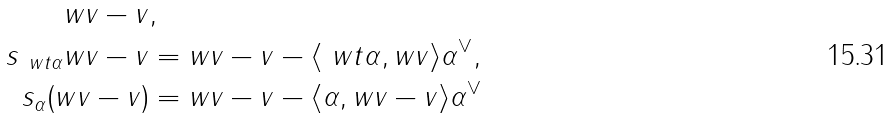<formula> <loc_0><loc_0><loc_500><loc_500>w v - v & , \\ s _ { \ w t \alpha } w v - v & = w v - v - \langle \ w t \alpha , w v \rangle \alpha ^ { \vee } , \\ s _ { \alpha } ( w v - v ) & = w v - v - \langle \alpha , w v - v \rangle \alpha ^ { \vee }</formula> 